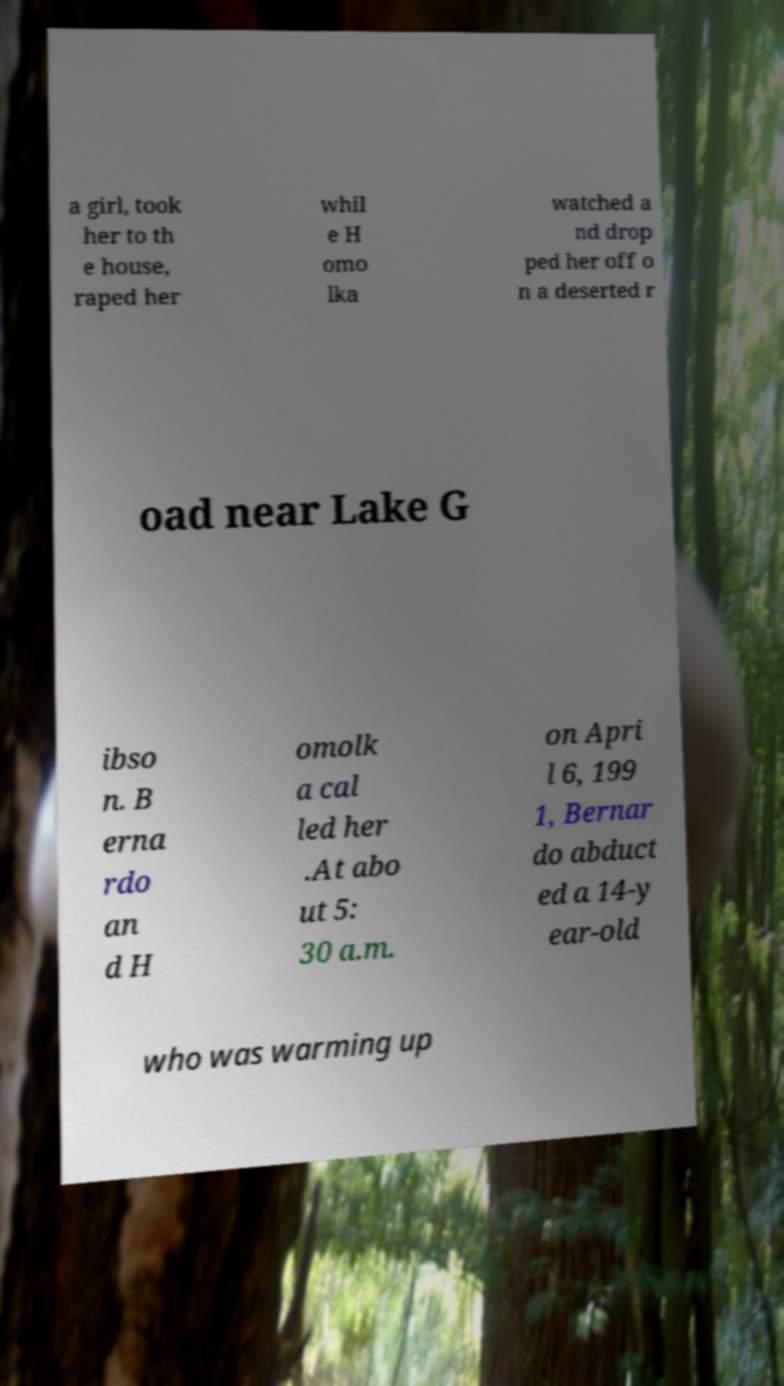For documentation purposes, I need the text within this image transcribed. Could you provide that? a girl, took her to th e house, raped her whil e H omo lka watched a nd drop ped her off o n a deserted r oad near Lake G ibso n. B erna rdo an d H omolk a cal led her .At abo ut 5: 30 a.m. on Apri l 6, 199 1, Bernar do abduct ed a 14-y ear-old who was warming up 